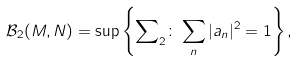<formula> <loc_0><loc_0><loc_500><loc_500>\mathcal { B } _ { 2 } ( M , N ) = \sup \left \{ { \sum } _ { 2 } \colon \sum _ { n } | a _ { n } | ^ { 2 } = 1 \right \} ,</formula> 